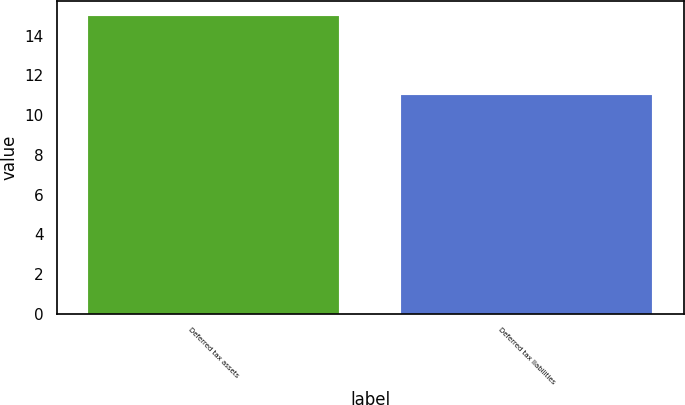<chart> <loc_0><loc_0><loc_500><loc_500><bar_chart><fcel>Deferred tax assets<fcel>Deferred tax liabilities<nl><fcel>15<fcel>11<nl></chart> 